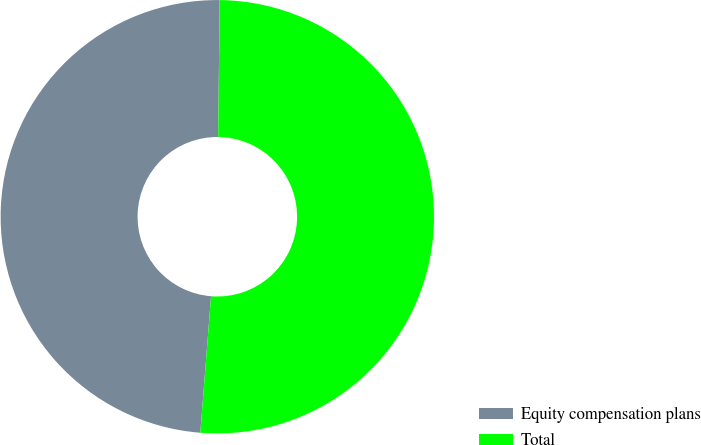<chart> <loc_0><loc_0><loc_500><loc_500><pie_chart><fcel>Equity compensation plans<fcel>Total<nl><fcel>48.92%<fcel>51.08%<nl></chart> 